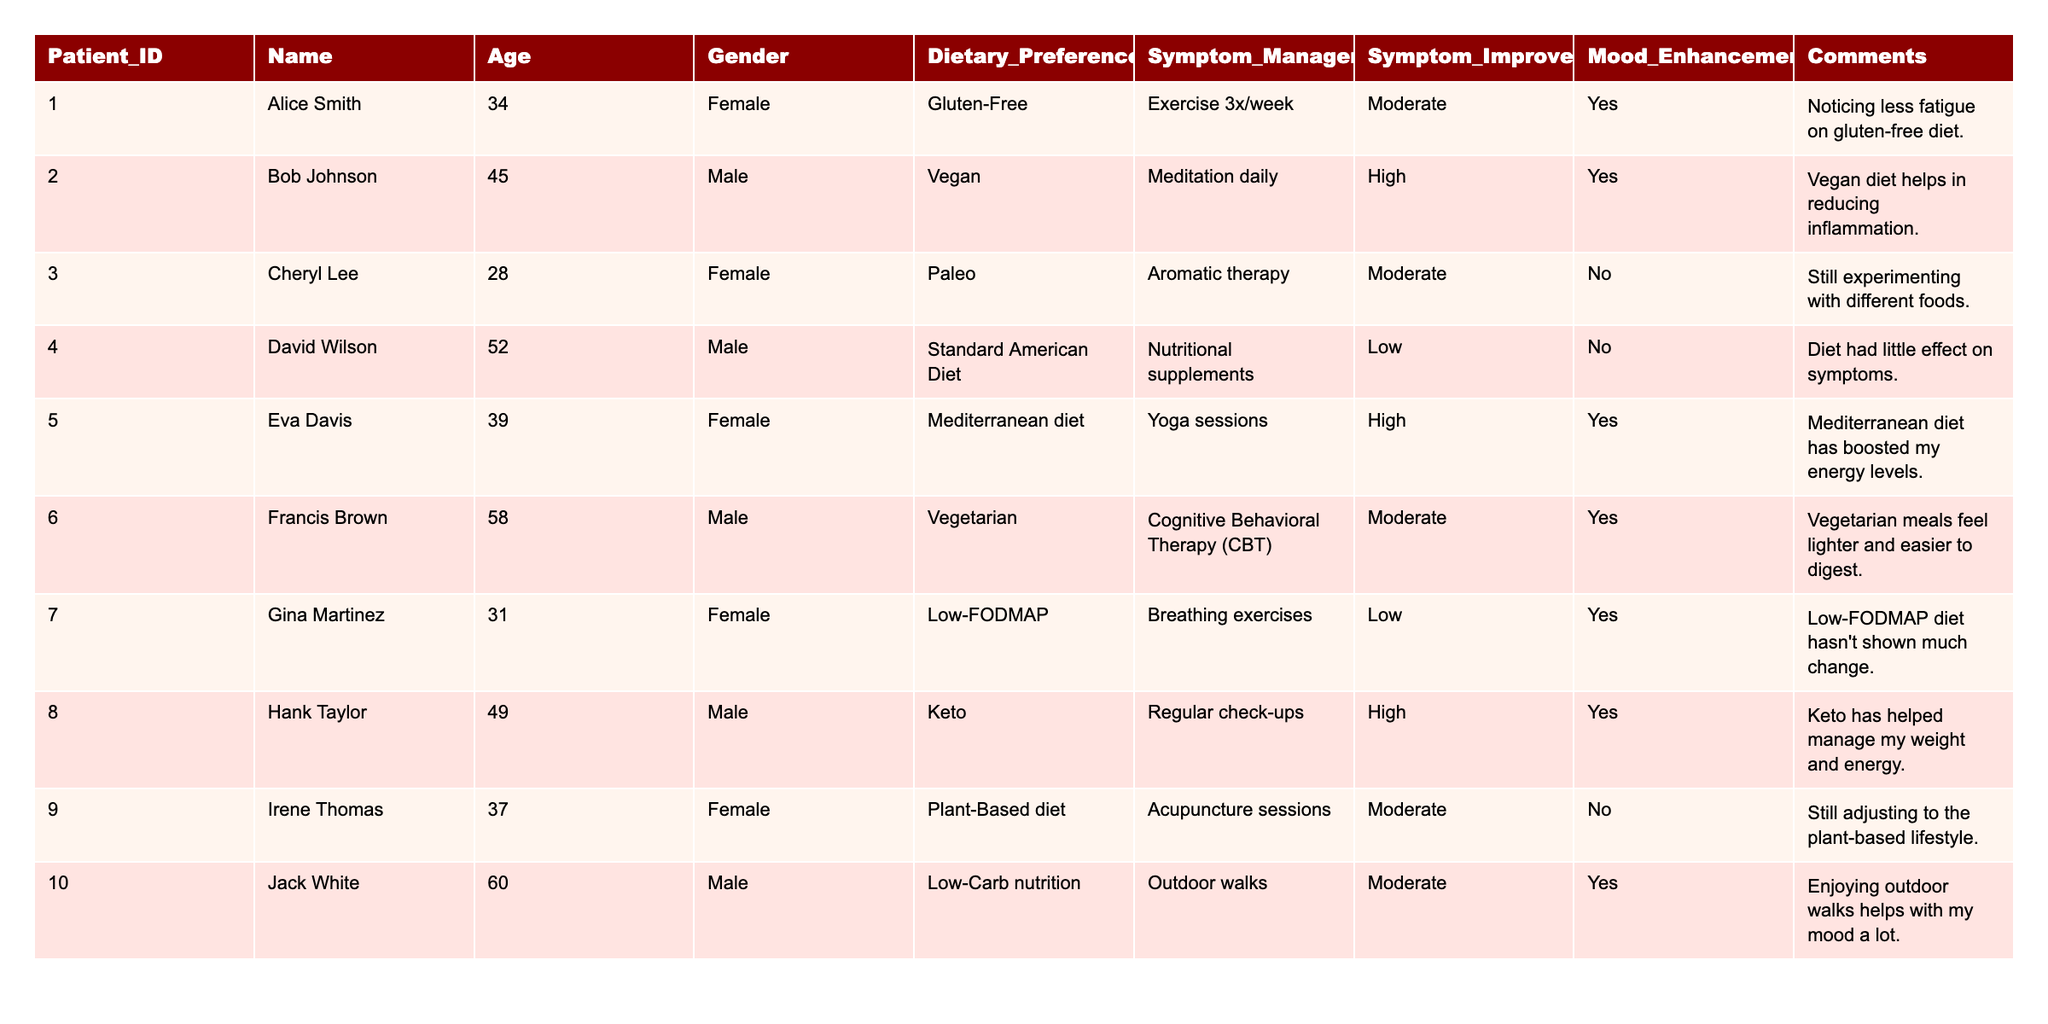What is the dietary preference of the oldest patient? The oldest patient is Jack White, who is 60 years old. Looking at the table, Jack White's dietary preference is Low-Carb nutrition.
Answer: Low-Carb nutrition How many patients reported a high level of symptom improvement? The table shows that three patients (Bob Johnson, Eva Davis, and Hank Taylor) reported a high level of symptom improvement.
Answer: 3 What is the symptom management technique used by the patient with the gluten-free diet? Alice Smith, who follows a gluten-free diet, manages her symptoms with exercise three times a week.
Answer: Exercise 3x/week Do any vegetarians report low symptom improvement levels? Yes, Francis Brown, who follows a vegetarian diet, reported a low level of symptom improvement.
Answer: Yes Which dietary preference corresponds to the patients who noted no mood enhancement? The patients who noted no mood enhancement are Cheryl Lee (Paleo diet) and Irene Thomas (Plant-Based diet). Both dietary preferences correspond to mid-level symptom improvement.
Answer: Paleo and Plant-Based diet What is the average age of patients who have a Mediterranean diet? There is one patient, Eva Davis, who has a Mediterranean diet and is 39 years old. Therefore, the average age is simply her age.
Answer: 39 Which symptom management technique is associated with the vegan dietary preference? Bob Johnson follows a vegan diet and uses meditation daily as his symptom management technique.
Answer: Meditation daily How many patients reported a "Moderate" level of symptom improvement? In the table, five patients reported a "Moderate" level of symptom improvement. This includes Alice Smith, Cheryl Lee, Francis Brown, Irene Thomas, and Jack White.
Answer: 5 Are most patients’ dietary preferences plant-based? No, the majority of the dietary preferences listed are not plant-based, as there are more patients with dietary preferences such as Standard American Diet, Keto, Mediterranean, and others.
Answer: No What pattern emerges when comparing symptom management techniques of patients who follow the Paleo and Mediterranean diets? Cheryl Lee with a Paleo diet uses Aromatherapy, while Eva Davis with a Mediterranean diet uses Yoga sessions. Both suggest that alternative therapies and physical activity are being utilized.
Answer: Aromatherapy and Yoga sessions Summarize the relationship between mood enhancement and dietary preferences for the patients listed. Looking at the table, both Bob Johnson and Eva Davis report a high level of mood enhancement with their vegan and Mediterranean diets, suggesting a positive relationship. In contrast, Cheryl Lee's Paleo diet did not enhance her mood.
Answer: Positive for Vegan and Mediterranean; negative for Paleo 